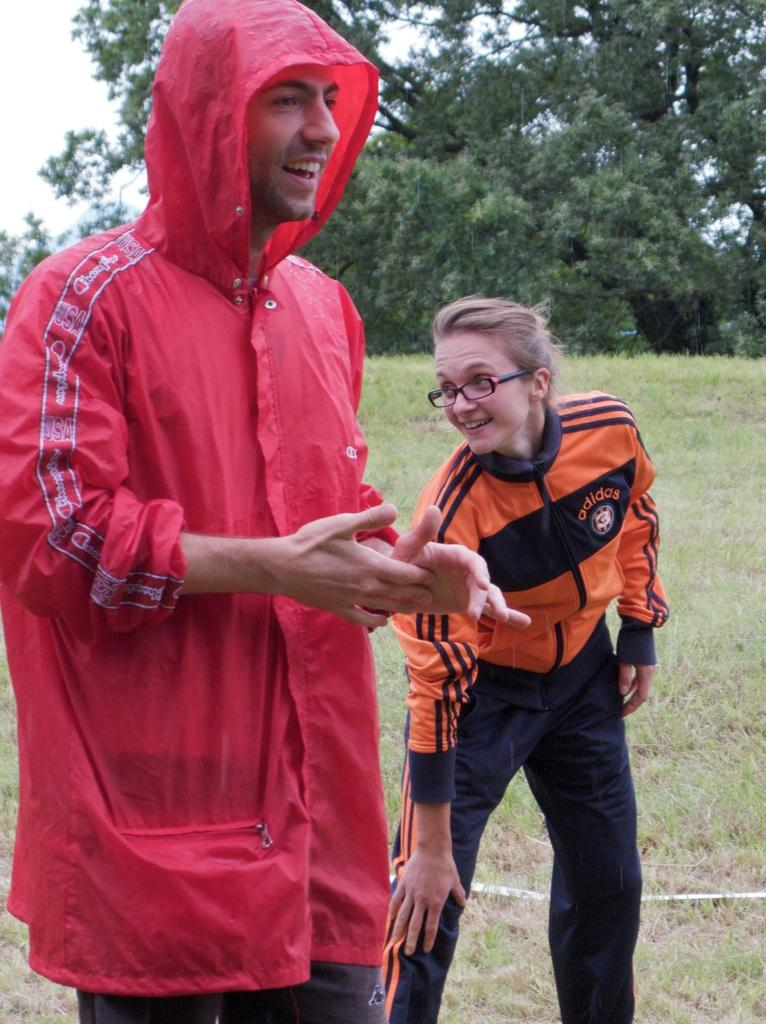How many people are in the image? There are two persons standing in the middle of the image. What are the people doing in the image? The persons are smiling. What type of ground is visible in the image? There is grass visible in the image. What can be seen behind the people in the image? There are trees behind the persons. What is visible in the background of the image? The sky is visible behind the trees. What type of sheet is being used to cover the value in the image? There is no value or sheet present in the image; it features two people standing in a natural setting. 